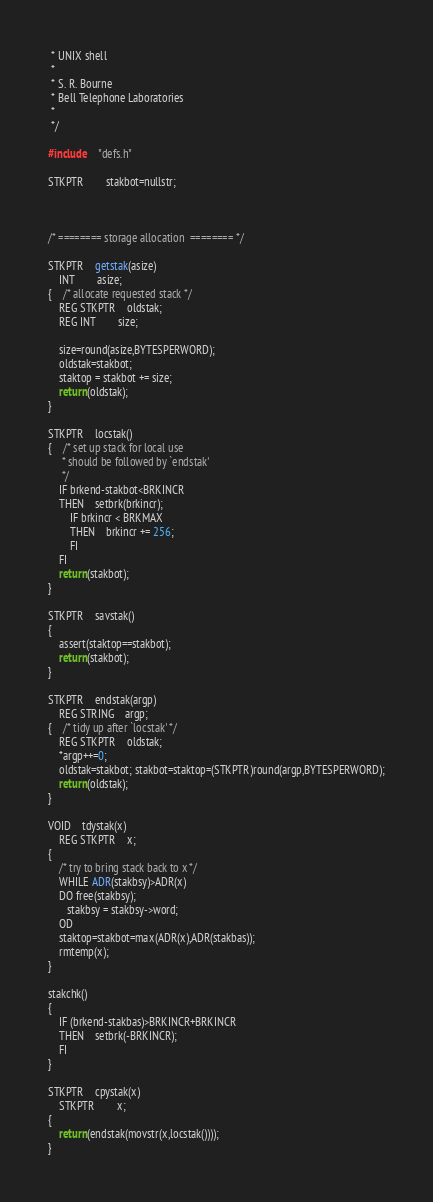Convert code to text. <code><loc_0><loc_0><loc_500><loc_500><_C_> * UNIX shell
 *
 * S. R. Bourne
 * Bell Telephone Laboratories
 *
 */

#include	"defs.h"

STKPTR		stakbot=nullstr;



/* ========	storage allocation	======== */

STKPTR	getstak(asize)
	INT		asize;
{	/* allocate requested stack */
	REG STKPTR	oldstak;
	REG INT		size;

	size=round(asize,BYTESPERWORD);
	oldstak=stakbot;
	staktop = stakbot += size;
	return(oldstak);
}

STKPTR	locstak()
{	/* set up stack for local use
	 * should be followed by `endstak'
	 */
	IF brkend-stakbot<BRKINCR
	THEN	setbrk(brkincr);
		IF brkincr < BRKMAX
		THEN	brkincr += 256;
		FI
	FI
	return(stakbot);
}

STKPTR	savstak()
{
	assert(staktop==stakbot);
	return(stakbot);
}

STKPTR	endstak(argp)
	REG STRING	argp;
{	/* tidy up after `locstak' */
	REG STKPTR	oldstak;
	*argp++=0;
	oldstak=stakbot; stakbot=staktop=(STKPTR)round(argp,BYTESPERWORD);
	return(oldstak);
}

VOID	tdystak(x)
	REG STKPTR 	x;
{
	/* try to bring stack back to x */
	WHILE ADR(stakbsy)>ADR(x)
	DO free(stakbsy);
	   stakbsy = stakbsy->word;
	OD
	staktop=stakbot=max(ADR(x),ADR(stakbas));
	rmtemp(x);
}

stakchk()
{
	IF (brkend-stakbas)>BRKINCR+BRKINCR
	THEN	setbrk(-BRKINCR);
	FI
}

STKPTR	cpystak(x)
	STKPTR		x;
{
	return(endstak(movstr(x,locstak())));
}
</code> 